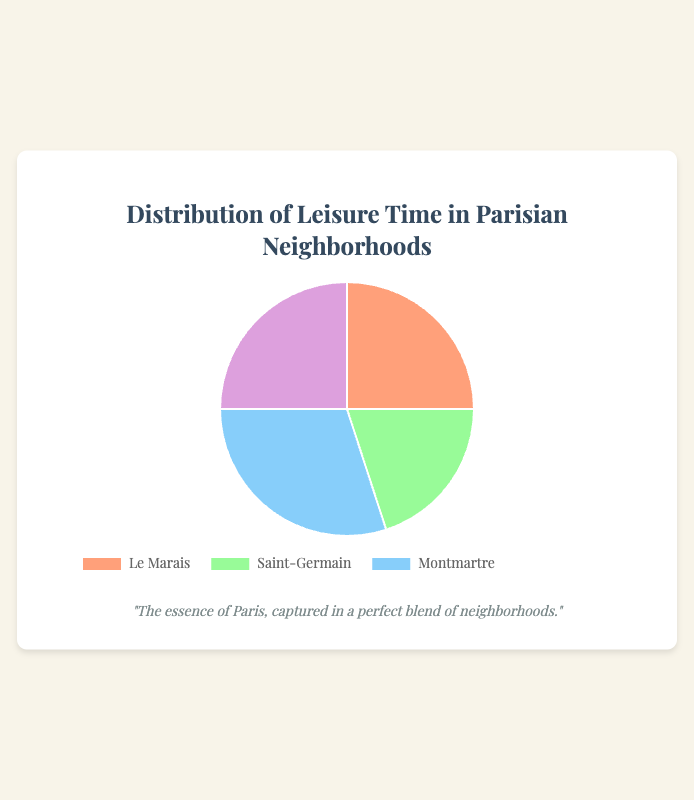What percentage of the leisure time is spent in the Latin Quarter? According to the data in the pie chart, the percentage of leisure time spent in the Latin Quarter is directly mentioned.
Answer: 25% How much more time is spent in Montmartre compared to Saint-Germain? The percentage of time spent in Montmartre is 30% and in Saint-Germain is 20%, so the difference is 30% - 20%.
Answer: 10% Which neighborhoods have an equal distribution of leisure time? The pie chart shows that Le Marais and the Latin Quarter both have a leisure time distribution of 25%.
Answer: Le Marais and Latin Quarter What is the total percentage of time spent in Le Marais and Montmartre combined? Adding the percentages for Le Marais (25%) and Montmartre (30%) gives 25% + 30%.
Answer: 55% Which neighborhood has the least amount of leisure time spent in it? According to the chart, the neighborhood with the smallest percentage is Saint-Germain with 20%.
Answer: Saint-Germain How is time distributed between Le Marais and the Latin Quarter compared to Montmartre? Le Marais and the Latin Quarter together cover 25% + 25% = 50%, while Montmartre alone covers 30%. So, Le Marais and Latin Quarter together is more.
Answer: More in Le Marais and Latin Quarter combined What is the difference in percentage between the neighborhood with the most and the least leisure time? The neighborhood with the most time is Montmartre (30%) and the least is Saint-Germain (20%), so the difference is 30% - 20%.
Answer: 10% What color is used to represent the neighborhood with the smallest portion of leisure time? The pie chart uses a specific color to visually represent each neighborhood, Saint-Germain is represented by the green segment.
Answer: Green If time was equally spent in all neighborhoods, what would the percentage be for each, and how does it compare to each current value? For equal distribution in four neighborhoods, each would be 100% / 4 = 25%. Le Marais and Latin Quarter are already at 25%, Saint-Germain is less at 20%, and Montmartre is more at 30%.
Answer: 25%, Le Marais and Latin Quarter equal, Saint-Germain less, Montmartre more 